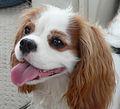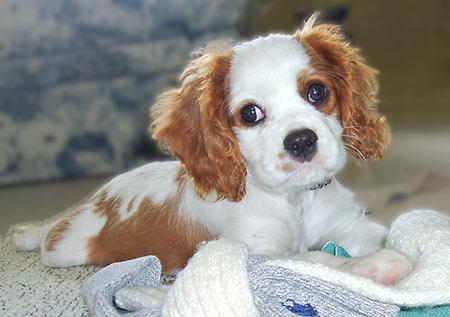The first image is the image on the left, the second image is the image on the right. Evaluate the accuracy of this statement regarding the images: "One of the images contains a dog that is standing.". Is it true? Answer yes or no. No. 